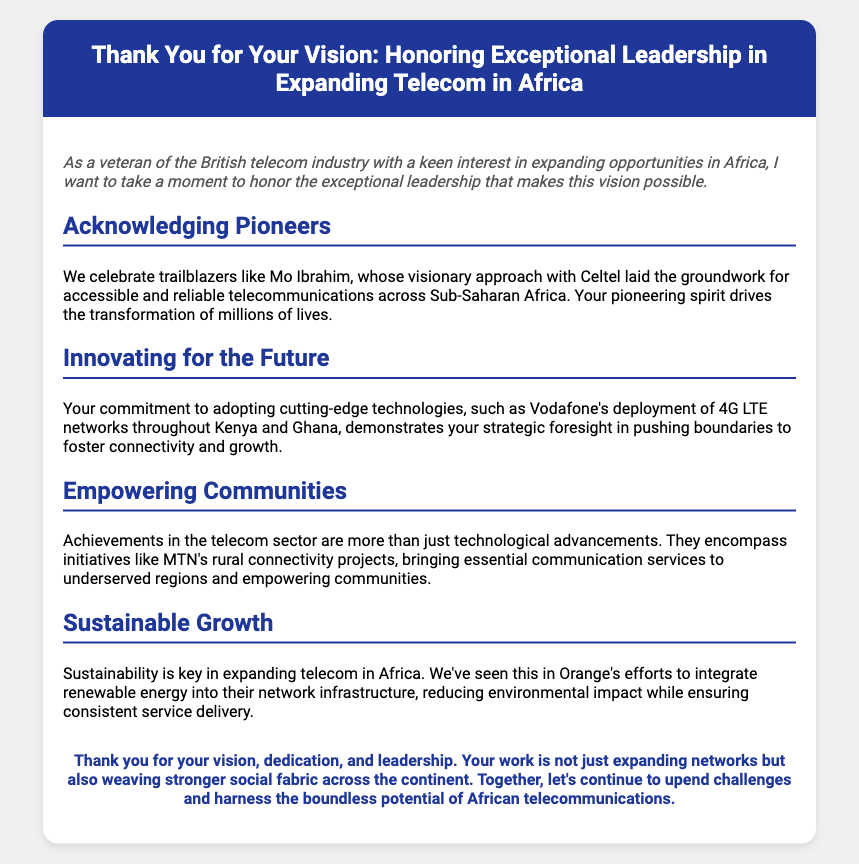What is the title of the document? The title is prominently displayed in the header section of the card.
Answer: Thank You for Your Vision: Honoring Exceptional Leadership in Expanding Telecom in Africa Who is mentioned as a pioneer in the document? The section on acknowledging pioneers specifically names an influential figure in telecom expansion.
Answer: Mo Ibrahim What is the key technology adopted by Vodafone mentioned in the document? The document refers to a specific technological advancement linked to Vodafone's expansion efforts in Africa.
Answer: 4G LTE Which telecom company is associated with rural connectivity projects? The document highlights initiatives aimed at empowering communities through connectivity services.
Answer: MTN What is the focus of Orange's sustainability efforts? The document describes specific measures taken by ORange to maintain eco-friendliness in their operations.
Answer: Renewable energy How does the document describe the impact of technological achievements? The document emphasizes the broader implications of telecom advancements beyond technology itself.
Answer: Empowering communities What style does the closing statement in the document emphasize? The closing remarks reflect on the overall importance and vision of the leaders in the telecom sector.
Answer: Leadership What color is used for the header background? The document specifies the color used in the header, which sets the theme for the card.
Answer: #1e3799 